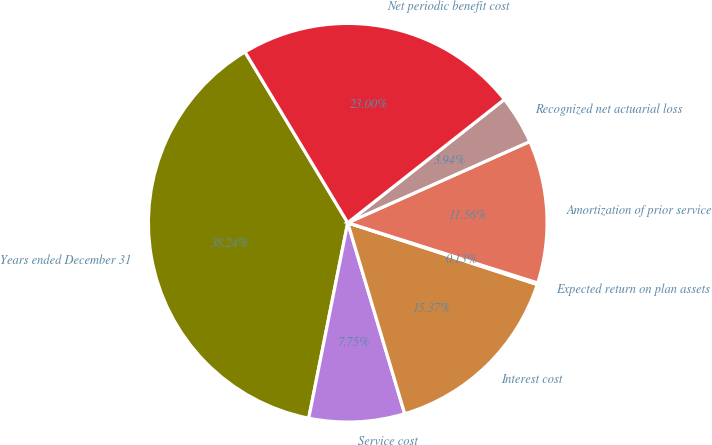<chart> <loc_0><loc_0><loc_500><loc_500><pie_chart><fcel>Years ended December 31<fcel>Service cost<fcel>Interest cost<fcel>Expected return on plan assets<fcel>Amortization of prior service<fcel>Recognized net actuarial loss<fcel>Net periodic benefit cost<nl><fcel>38.24%<fcel>7.75%<fcel>15.37%<fcel>0.13%<fcel>11.56%<fcel>3.94%<fcel>23.0%<nl></chart> 